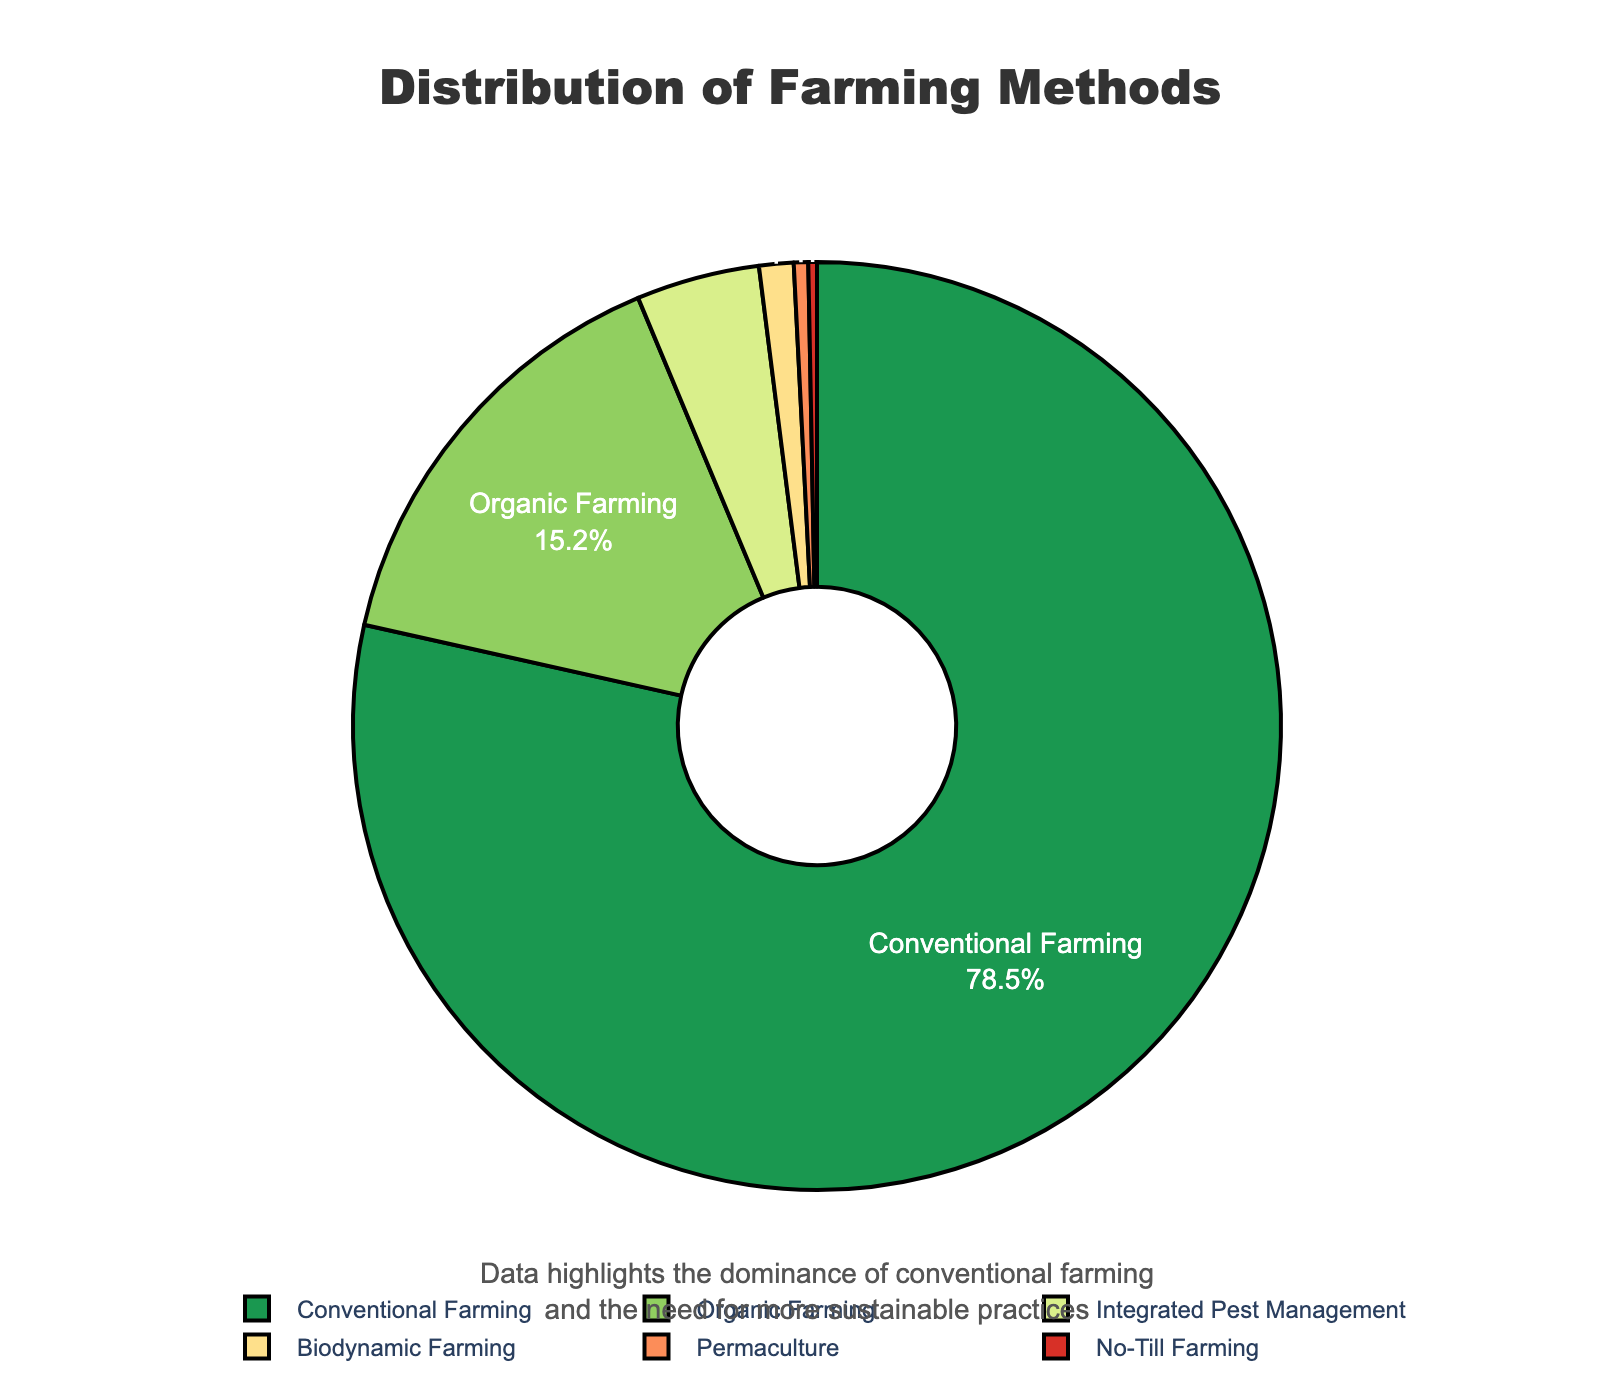Which farming method is the most prevalent? By looking at the figure, we see that Conventional Farming has the largest portion of the pie chart, with 78.5%.
Answer: Conventional Farming How much more prevalent is Conventional Farming compared to Organic Farming? The percentage for Conventional Farming is 78.5% and for Organic Farming is 15.2%. The difference is 78.5 - 15.2.
Answer: 63.3% Which farming methods make up less than 1% of the overall farming methods? The visual representation shows that both Permaculture (0.5%) and No-Till Farming (0.3%) segments are smaller than 1%.
Answer: Permaculture and No-Till Farming What proportion of farming methods are alternative to Conventional Farming? Sum the percentages of Organic Farming, Integrated Pest Management, Biodynamic Farming, Permaculture, and No-Till Farming. The sum is 15.2% + 4.3% + 1.2% + 0.5% + 0.3%.
Answer: 21.5% Which farming method is depicted in dark green on the pie chart? By observing the pie chart, we see that the segment colored dark green represents Conventional Farming.
Answer: Conventional Farming Are Integrated Pest Management and Biodynamic Farming together greater than Organic Farming alone? Sum the percentages for Integrated Pest Management and Biodynamic Farming: 4.3% + 1.2%. Compare this sum to the percentage for Organic Farming, which is 15.2%.
Answer: No What is the percentage difference between Integrated Pest Management and Biodynamic Farming? The percentage for Integrated Pest Management is 4.3%, and for Biodynamic Farming, it is 1.2%. The difference is 4.3 - 1.2.
Answer: 3.1% How is the need for more sustainable practices visually emphasized in the chart? The annotation at the bottom of the chart highlights the dominance of conventional farming and hints at the need for more sustainable practices.
Answer: Annotation text Which two farming methods have the smallest percentage representation? By looking at the two smallest slices of the pie chart, we see that Permaculture (0.5%) and No-Till Farming (0.3%) have the smallest percentages.
Answer: Permaculture and No-Till Farming 